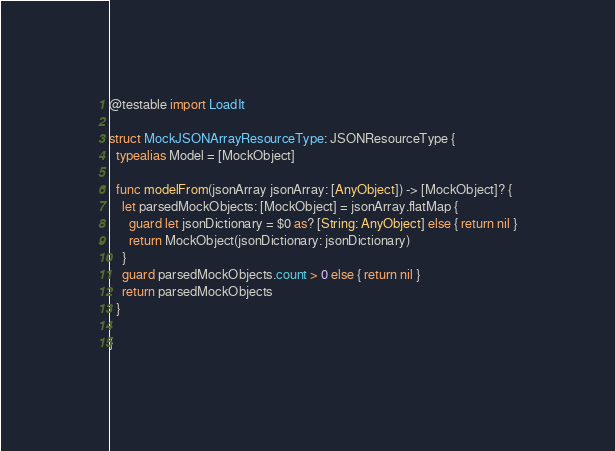<code> <loc_0><loc_0><loc_500><loc_500><_Swift_>@testable import LoadIt

struct MockJSONArrayResourceType: JSONResourceType {
  typealias Model = [MockObject]
  
  func modelFrom(jsonArray jsonArray: [AnyObject]) -> [MockObject]? {
    let parsedMockObjects: [MockObject] = jsonArray.flatMap {
      guard let jsonDictionary = $0 as? [String: AnyObject] else { return nil }
      return MockObject(jsonDictionary: jsonDictionary)
    }
    guard parsedMockObjects.count > 0 else { return nil }
    return parsedMockObjects
  }
  
}
</code> 